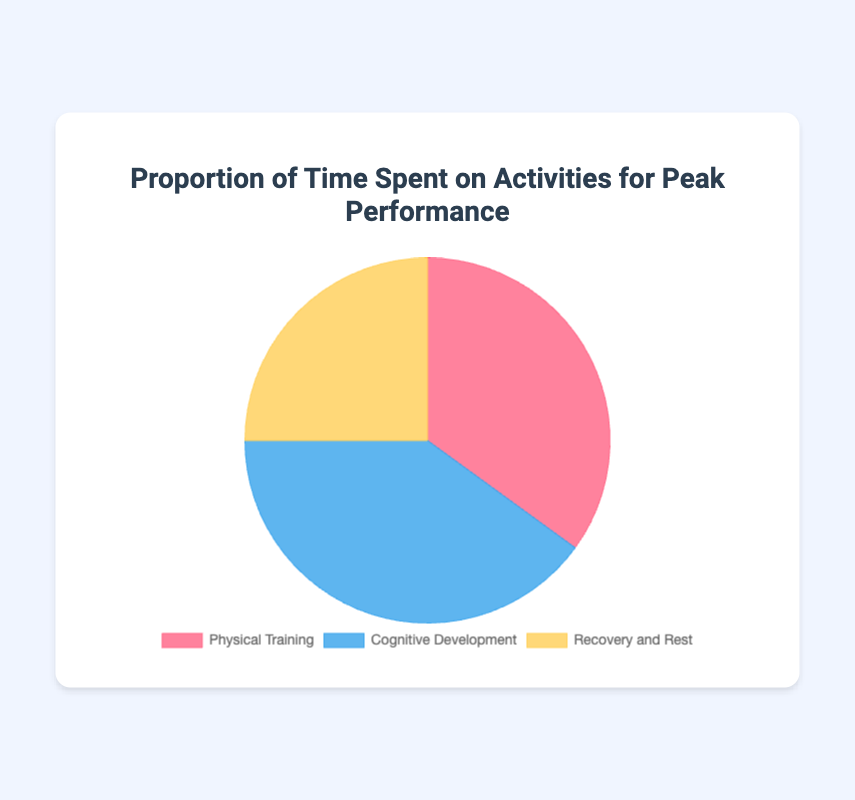Which activity takes up the highest proportion of time? The chart shows the percentage of time spent on different activities. Cognitive Development has the highest proportion at 40%.
Answer: Cognitive Development How much more time is spent on Cognitive Development compared to Recovery and Rest? Cognitive Development has a proportion of 40%, while Recovery and Rest has 25%. The difference is 40% - 25% = 15%.
Answer: 15% What is the total proportion of time spent on Physical Training and Cognitive Development? The proportion of time spent on Physical Training is 35% and on Cognitive Development is 40%. Adding these together gives 35% + 40% = 75%.
Answer: 75% Which segments of the pie chart are represented by cool colors? Generally, blue is considered a cool color. According to the chart, Cognitive Development is represented by blue.
Answer: Cognitive Development If the total available time is 24 hours, how many hours are spent on Recovery and Rest? Recovery and Rest takes up 25% of the total time. Therefore, 0.25 * 24 = 6 hours.
Answer: 6 hours Which activity has the smallest proportion, and how does it compare to the activity with the largest proportion? Recovery and Rest has the smallest proportion at 25%, while Cognitive Development has the largest at 40%. The difference is 40% - 25% = 15%.
Answer: Recovery and Rest, 15% What activity is represented by the pinkish-red color, and what is its proportion of the total time? The pinkish-red color in the chart represents Physical Training, which takes up 35% of the total time.
Answer: Physical Training, 35% By how much does the sum of times spent on Cognitive Development and Recovery and Rest exceed the time spent on Physical Training? Cognitive Development and Recovery and Rest together constitute 40% + 25% = 65%. Physical Training alone is 35%. The difference is 65% - 35% = 30%.
Answer: 30% What is the difference in proportions between the most time-consuming and the least time-consuming activities? The most time-consuming activity is Cognitive Development at 40%, and the least is Recovery and Rest at 25%. The difference is 40% - 25% = 15%.
Answer: 15% What proportion of time is spent on activities other than Physical Training? The proportion of time spent on activities other than Physical Training includes Cognitive Development (40%) and Recovery and Rest (25%). Adding these gives 40% + 25% = 65%.
Answer: 65% 